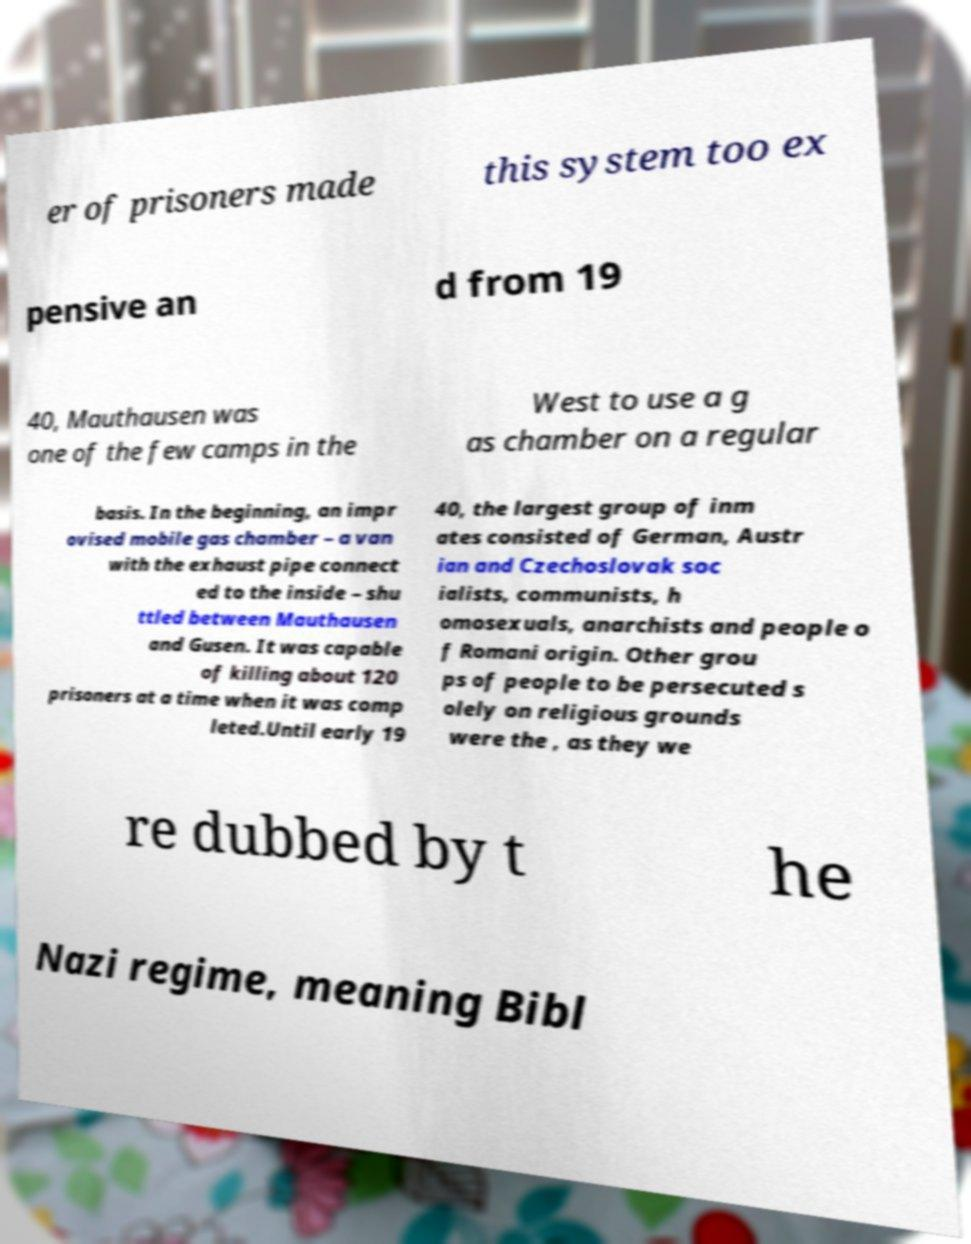Could you assist in decoding the text presented in this image and type it out clearly? er of prisoners made this system too ex pensive an d from 19 40, Mauthausen was one of the few camps in the West to use a g as chamber on a regular basis. In the beginning, an impr ovised mobile gas chamber – a van with the exhaust pipe connect ed to the inside – shu ttled between Mauthausen and Gusen. It was capable of killing about 120 prisoners at a time when it was comp leted.Until early 19 40, the largest group of inm ates consisted of German, Austr ian and Czechoslovak soc ialists, communists, h omosexuals, anarchists and people o f Romani origin. Other grou ps of people to be persecuted s olely on religious grounds were the , as they we re dubbed by t he Nazi regime, meaning Bibl 